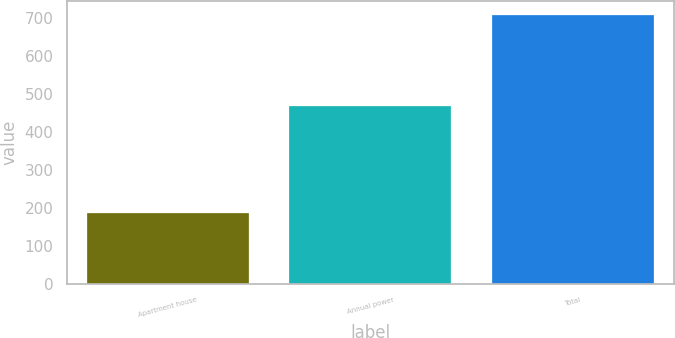Convert chart to OTSL. <chart><loc_0><loc_0><loc_500><loc_500><bar_chart><fcel>Apartment house<fcel>Annual power<fcel>Total<nl><fcel>186<fcel>468<fcel>707<nl></chart> 